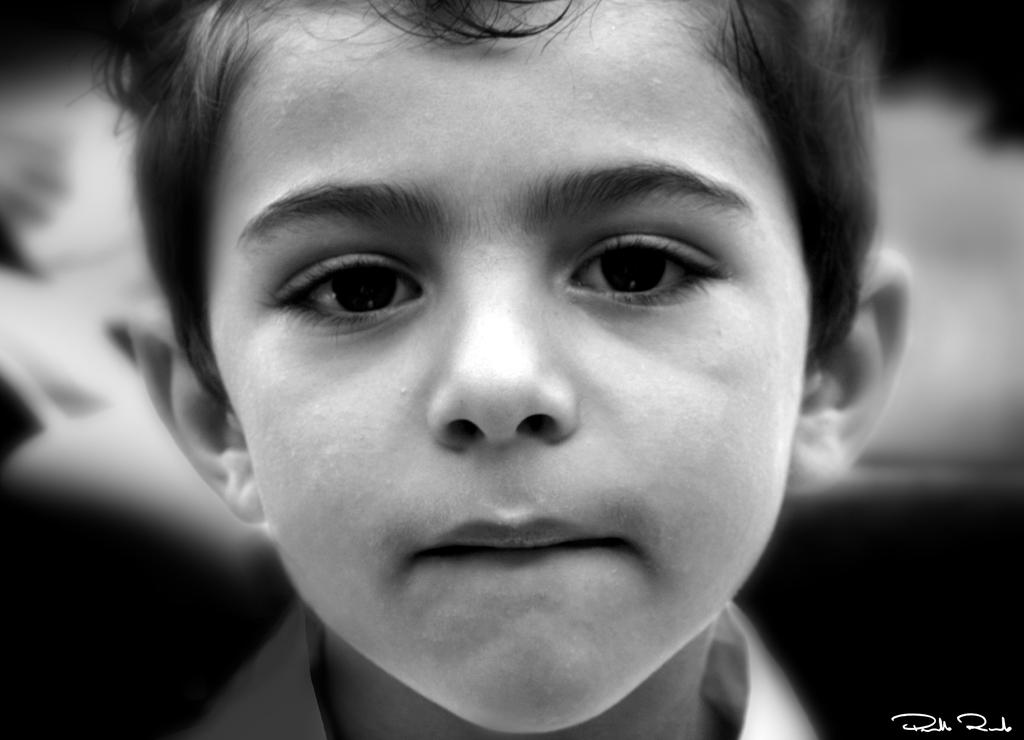Who is present in the image? There is a boy in the image. Can you describe any additional features of the image? There is a watermark at the bottom right corner of the image. How many spiders are crawling on the boy in the image? There are no spiders present in the image; it only features a boy and a watermark. What type of feather can be seen in the boy's hand in the image? There is no feather present in the boy's hand or anywhere else in the image. 